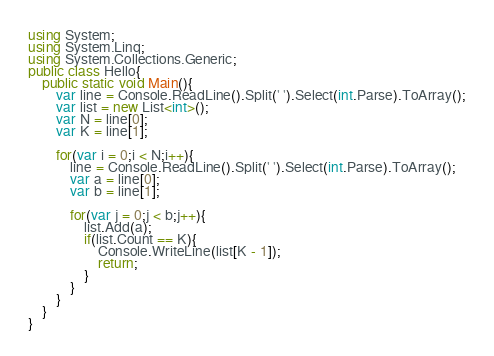Convert code to text. <code><loc_0><loc_0><loc_500><loc_500><_C#_>using System;
using System.Linq;
using System.Collections.Generic;
public class Hello{
    public static void Main(){
        var line = Console.ReadLine().Split(' ').Select(int.Parse).ToArray();
        var list = new List<int>();
        var N = line[0];
        var K = line[1];
        
        for(var i = 0;i < N;i++){
            line = Console.ReadLine().Split(' ').Select(int.Parse).ToArray();
            var a = line[0];
            var b = line[1];
            
            for(var j = 0;j < b;j++){
                list.Add(a);
                if(list.Count == K){
                    Console.WriteLine(list[K - 1]);
                    return;
                }
            }
        }
    }
}
</code> 